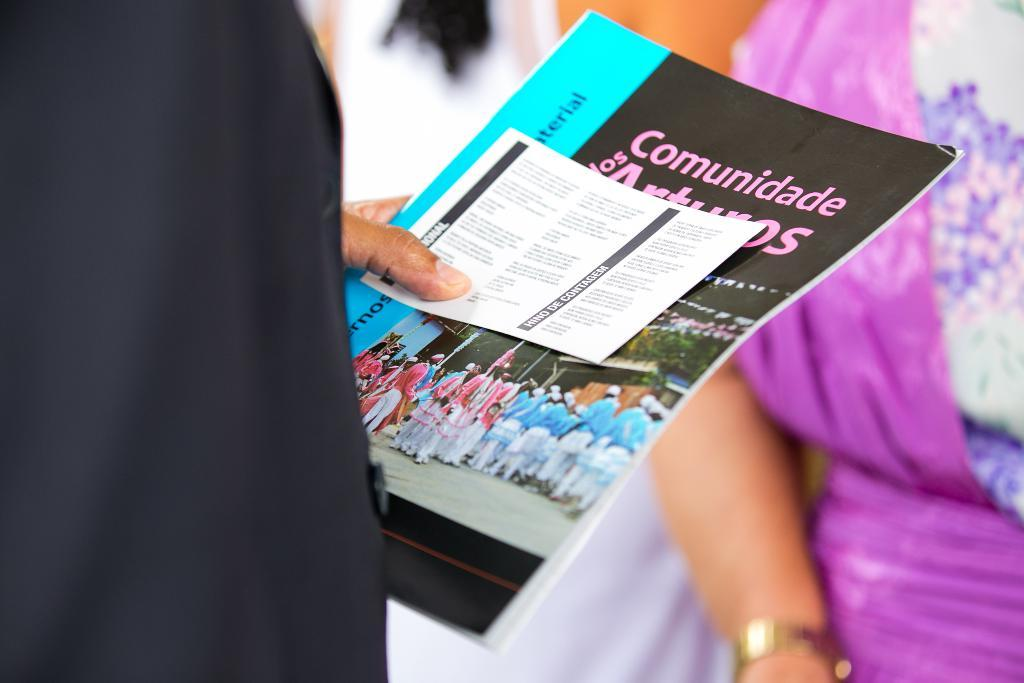What is the person in the foreground of the image doing? The person is standing in the foreground of the image and holding a book and a paper. Can you describe the objects the person is holding? The person is holding a book and a paper. How many people are visible in the image? There are three people in the image: one person in the foreground and two persons in the background. What type of map can be seen in the image? There is no map present in the image. Can you describe the bee's activity in the image? There are no bees present in the image. 